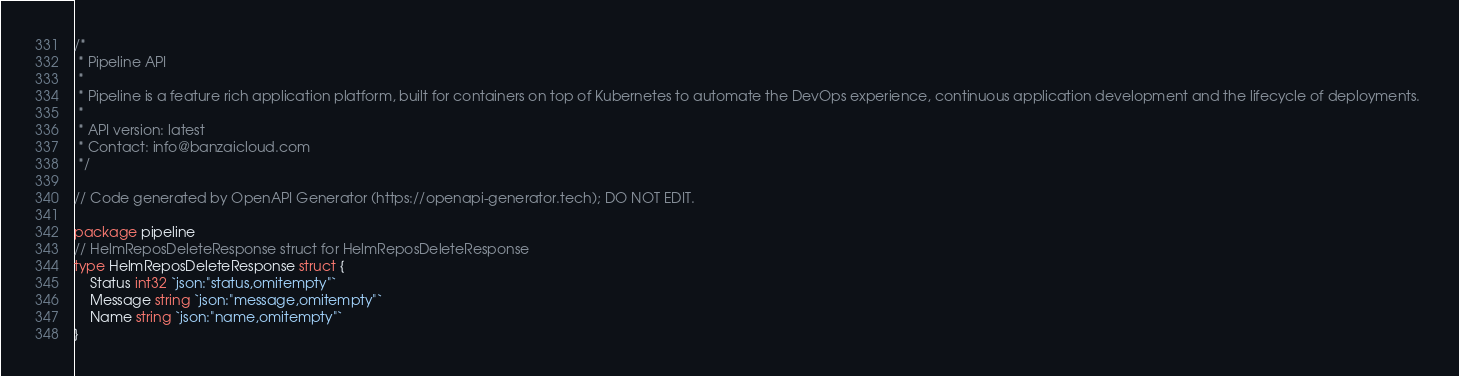Convert code to text. <code><loc_0><loc_0><loc_500><loc_500><_Go_>/*
 * Pipeline API
 *
 * Pipeline is a feature rich application platform, built for containers on top of Kubernetes to automate the DevOps experience, continuous application development and the lifecycle of deployments. 
 *
 * API version: latest
 * Contact: info@banzaicloud.com
 */

// Code generated by OpenAPI Generator (https://openapi-generator.tech); DO NOT EDIT.

package pipeline
// HelmReposDeleteResponse struct for HelmReposDeleteResponse
type HelmReposDeleteResponse struct {
	Status int32 `json:"status,omitempty"`
	Message string `json:"message,omitempty"`
	Name string `json:"name,omitempty"`
}
</code> 